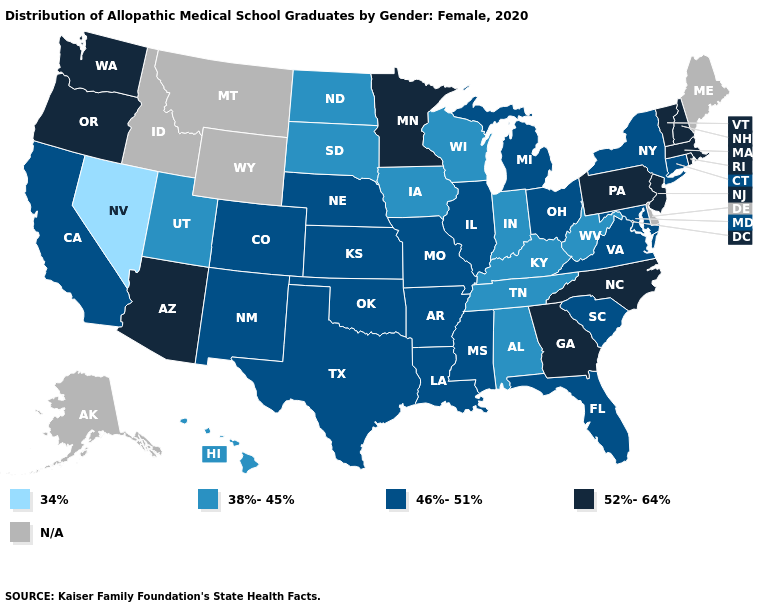Name the states that have a value in the range 46%-51%?
Keep it brief. Arkansas, California, Colorado, Connecticut, Florida, Illinois, Kansas, Louisiana, Maryland, Michigan, Mississippi, Missouri, Nebraska, New Mexico, New York, Ohio, Oklahoma, South Carolina, Texas, Virginia. What is the value of Maine?
Give a very brief answer. N/A. What is the value of Alaska?
Answer briefly. N/A. What is the highest value in the USA?
Quick response, please. 52%-64%. What is the value of New York?
Short answer required. 46%-51%. Name the states that have a value in the range 46%-51%?
Answer briefly. Arkansas, California, Colorado, Connecticut, Florida, Illinois, Kansas, Louisiana, Maryland, Michigan, Mississippi, Missouri, Nebraska, New Mexico, New York, Ohio, Oklahoma, South Carolina, Texas, Virginia. What is the highest value in states that border Oregon?
Write a very short answer. 52%-64%. What is the highest value in the USA?
Answer briefly. 52%-64%. Does Minnesota have the highest value in the USA?
Short answer required. Yes. What is the value of Arizona?
Concise answer only. 52%-64%. What is the lowest value in states that border New Jersey?
Answer briefly. 46%-51%. Name the states that have a value in the range 34%?
Be succinct. Nevada. Name the states that have a value in the range 38%-45%?
Answer briefly. Alabama, Hawaii, Indiana, Iowa, Kentucky, North Dakota, South Dakota, Tennessee, Utah, West Virginia, Wisconsin. What is the highest value in the MidWest ?
Be succinct. 52%-64%. 